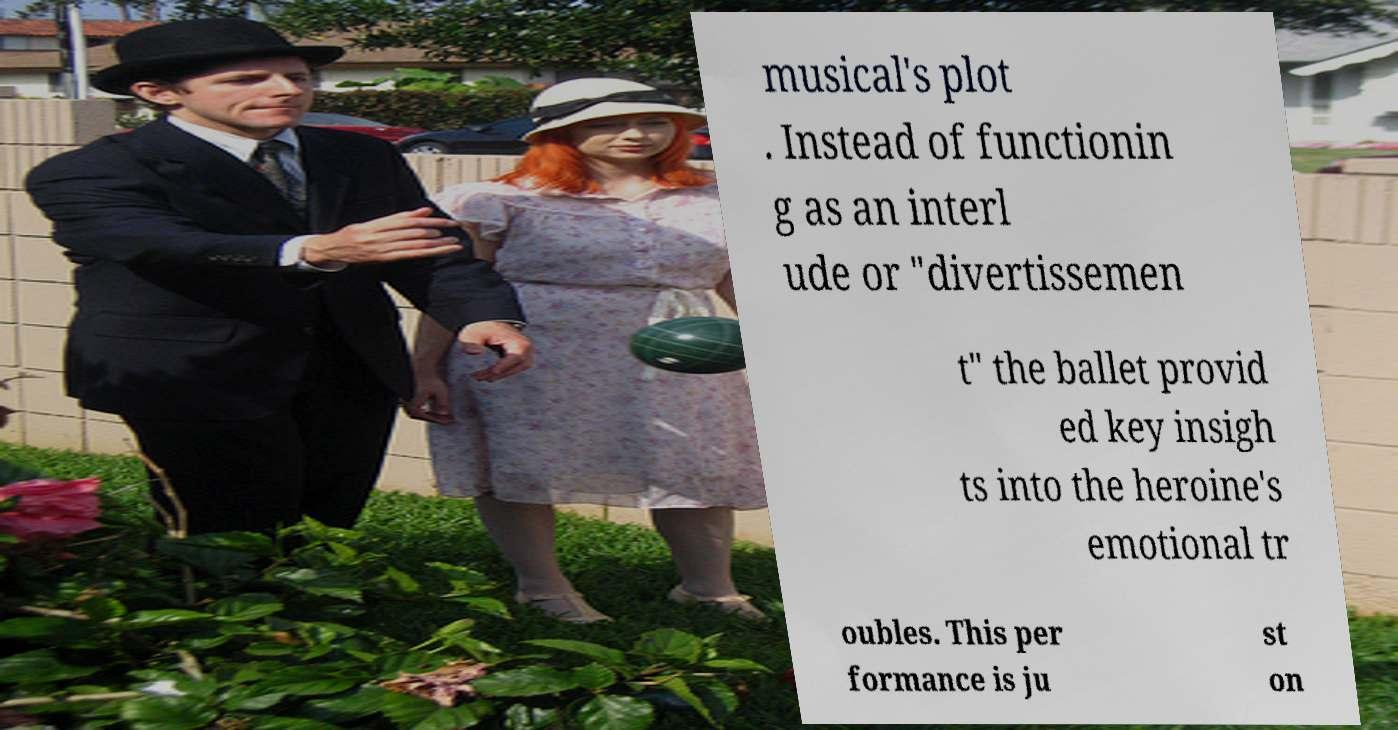There's text embedded in this image that I need extracted. Can you transcribe it verbatim? musical's plot . Instead of functionin g as an interl ude or "divertissemen t" the ballet provid ed key insigh ts into the heroine's emotional tr oubles. This per formance is ju st on 